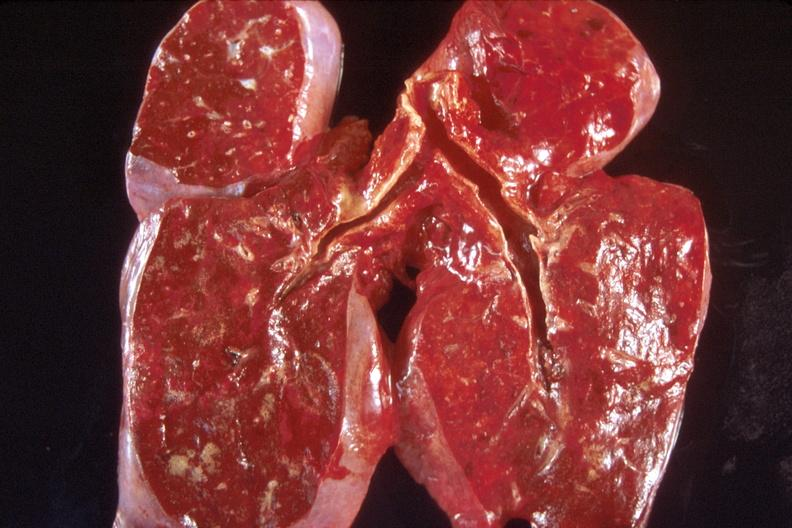what is present?
Answer the question using a single word or phrase. Respiratory 